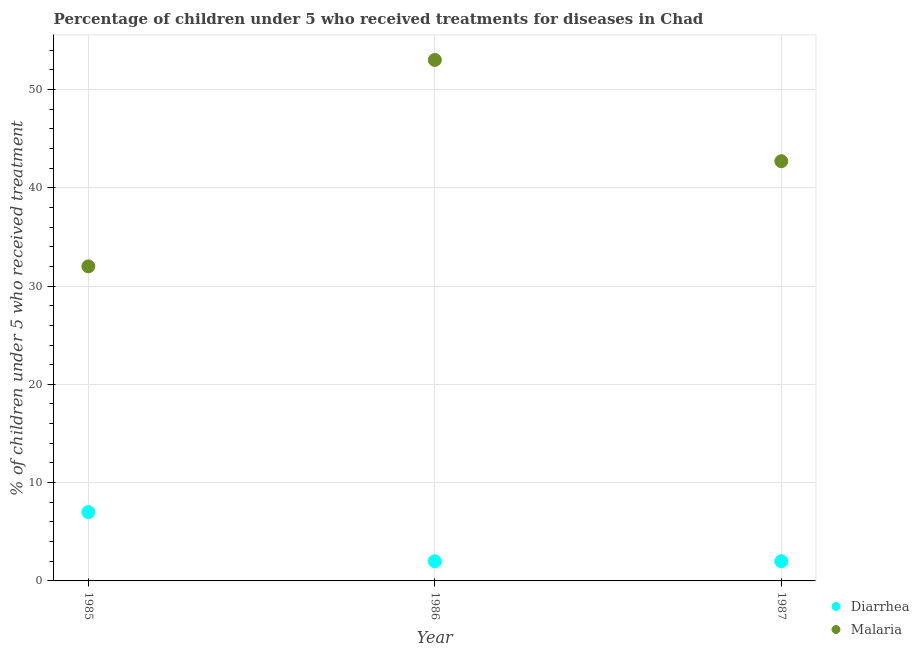What is the percentage of children who received treatment for diarrhoea in 1985?
Keep it short and to the point. 7. Across all years, what is the maximum percentage of children who received treatment for diarrhoea?
Ensure brevity in your answer.  7. Across all years, what is the minimum percentage of children who received treatment for malaria?
Offer a very short reply. 32. In which year was the percentage of children who received treatment for malaria minimum?
Ensure brevity in your answer.  1985. What is the total percentage of children who received treatment for malaria in the graph?
Your answer should be very brief. 127.7. What is the difference between the percentage of children who received treatment for diarrhoea in 1985 and the percentage of children who received treatment for malaria in 1987?
Give a very brief answer. -35.7. What is the average percentage of children who received treatment for diarrhoea per year?
Ensure brevity in your answer.  3.67. In the year 1985, what is the difference between the percentage of children who received treatment for diarrhoea and percentage of children who received treatment for malaria?
Give a very brief answer. -25. What is the ratio of the percentage of children who received treatment for malaria in 1985 to that in 1986?
Provide a short and direct response. 0.6. What is the difference between the highest and the second highest percentage of children who received treatment for diarrhoea?
Provide a succinct answer. 5. What is the difference between the highest and the lowest percentage of children who received treatment for diarrhoea?
Provide a short and direct response. 5. In how many years, is the percentage of children who received treatment for malaria greater than the average percentage of children who received treatment for malaria taken over all years?
Provide a succinct answer. 2. Is the percentage of children who received treatment for malaria strictly greater than the percentage of children who received treatment for diarrhoea over the years?
Your response must be concise. Yes. Does the graph contain grids?
Your answer should be compact. Yes. How are the legend labels stacked?
Keep it short and to the point. Vertical. What is the title of the graph?
Your answer should be very brief. Percentage of children under 5 who received treatments for diseases in Chad. What is the label or title of the Y-axis?
Ensure brevity in your answer.  % of children under 5 who received treatment. What is the % of children under 5 who received treatment in Malaria in 1985?
Your answer should be very brief. 32. What is the % of children under 5 who received treatment of Diarrhea in 1986?
Make the answer very short. 2. What is the % of children under 5 who received treatment of Diarrhea in 1987?
Offer a very short reply. 2. What is the % of children under 5 who received treatment in Malaria in 1987?
Your answer should be very brief. 42.7. Across all years, what is the minimum % of children under 5 who received treatment of Diarrhea?
Provide a short and direct response. 2. What is the total % of children under 5 who received treatment in Malaria in the graph?
Your answer should be compact. 127.7. What is the difference between the % of children under 5 who received treatment of Malaria in 1985 and that in 1986?
Your answer should be compact. -21. What is the difference between the % of children under 5 who received treatment in Diarrhea in 1985 and that in 1987?
Give a very brief answer. 5. What is the difference between the % of children under 5 who received treatment in Diarrhea in 1986 and that in 1987?
Your answer should be compact. 0. What is the difference between the % of children under 5 who received treatment in Malaria in 1986 and that in 1987?
Provide a short and direct response. 10.3. What is the difference between the % of children under 5 who received treatment of Diarrhea in 1985 and the % of children under 5 who received treatment of Malaria in 1986?
Your answer should be very brief. -46. What is the difference between the % of children under 5 who received treatment in Diarrhea in 1985 and the % of children under 5 who received treatment in Malaria in 1987?
Give a very brief answer. -35.7. What is the difference between the % of children under 5 who received treatment in Diarrhea in 1986 and the % of children under 5 who received treatment in Malaria in 1987?
Keep it short and to the point. -40.7. What is the average % of children under 5 who received treatment in Diarrhea per year?
Offer a very short reply. 3.67. What is the average % of children under 5 who received treatment of Malaria per year?
Offer a very short reply. 42.57. In the year 1986, what is the difference between the % of children under 5 who received treatment in Diarrhea and % of children under 5 who received treatment in Malaria?
Keep it short and to the point. -51. In the year 1987, what is the difference between the % of children under 5 who received treatment in Diarrhea and % of children under 5 who received treatment in Malaria?
Offer a very short reply. -40.7. What is the ratio of the % of children under 5 who received treatment in Malaria in 1985 to that in 1986?
Your response must be concise. 0.6. What is the ratio of the % of children under 5 who received treatment of Malaria in 1985 to that in 1987?
Provide a short and direct response. 0.75. What is the ratio of the % of children under 5 who received treatment of Malaria in 1986 to that in 1987?
Your answer should be very brief. 1.24. What is the difference between the highest and the second highest % of children under 5 who received treatment of Diarrhea?
Make the answer very short. 5. What is the difference between the highest and the lowest % of children under 5 who received treatment in Diarrhea?
Keep it short and to the point. 5. What is the difference between the highest and the lowest % of children under 5 who received treatment of Malaria?
Offer a terse response. 21. 